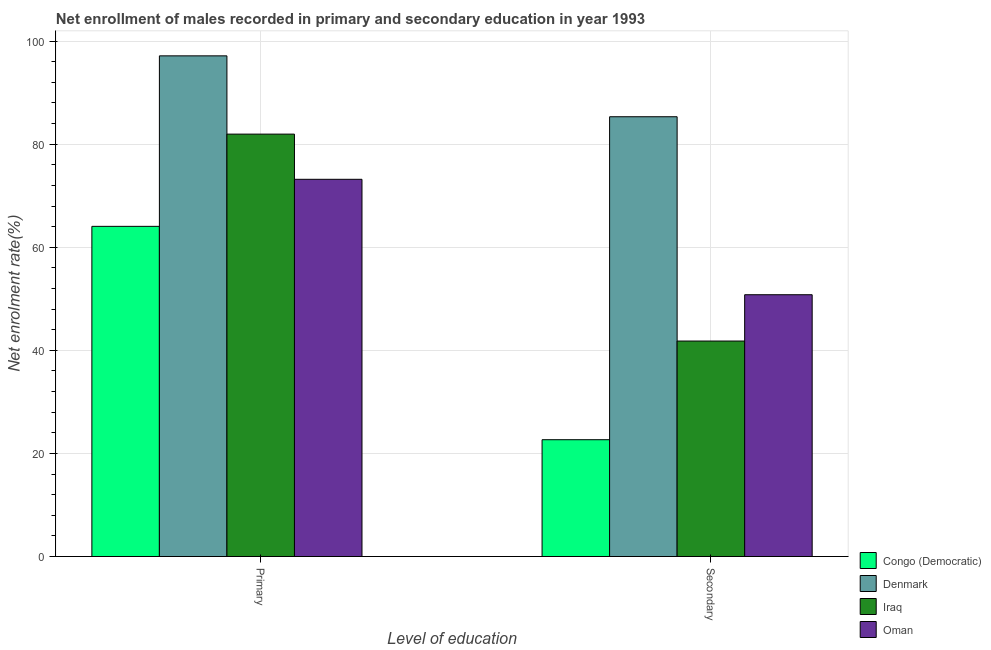How many different coloured bars are there?
Your answer should be compact. 4. Are the number of bars per tick equal to the number of legend labels?
Provide a succinct answer. Yes. Are the number of bars on each tick of the X-axis equal?
Offer a terse response. Yes. How many bars are there on the 1st tick from the right?
Make the answer very short. 4. What is the label of the 2nd group of bars from the left?
Your answer should be compact. Secondary. What is the enrollment rate in secondary education in Iraq?
Your response must be concise. 41.8. Across all countries, what is the maximum enrollment rate in primary education?
Provide a short and direct response. 97.13. Across all countries, what is the minimum enrollment rate in secondary education?
Offer a very short reply. 22.66. In which country was the enrollment rate in secondary education minimum?
Your answer should be compact. Congo (Democratic). What is the total enrollment rate in primary education in the graph?
Your response must be concise. 316.31. What is the difference between the enrollment rate in secondary education in Congo (Democratic) and that in Oman?
Your answer should be very brief. -28.13. What is the difference between the enrollment rate in primary education in Iraq and the enrollment rate in secondary education in Congo (Democratic)?
Your answer should be very brief. 59.29. What is the average enrollment rate in secondary education per country?
Give a very brief answer. 50.14. What is the difference between the enrollment rate in primary education and enrollment rate in secondary education in Oman?
Your answer should be compact. 22.39. What is the ratio of the enrollment rate in primary education in Denmark to that in Oman?
Give a very brief answer. 1.33. What does the 3rd bar from the left in Secondary represents?
Your response must be concise. Iraq. What does the 3rd bar from the right in Primary represents?
Ensure brevity in your answer.  Denmark. How many bars are there?
Give a very brief answer. 8. Are all the bars in the graph horizontal?
Your response must be concise. No. How many countries are there in the graph?
Keep it short and to the point. 4. Are the values on the major ticks of Y-axis written in scientific E-notation?
Your answer should be compact. No. Does the graph contain any zero values?
Provide a short and direct response. No. Does the graph contain grids?
Your answer should be very brief. Yes. Where does the legend appear in the graph?
Keep it short and to the point. Bottom right. What is the title of the graph?
Make the answer very short. Net enrollment of males recorded in primary and secondary education in year 1993. What is the label or title of the X-axis?
Offer a very short reply. Level of education. What is the label or title of the Y-axis?
Provide a short and direct response. Net enrolment rate(%). What is the Net enrolment rate(%) of Congo (Democratic) in Primary?
Your answer should be compact. 64.05. What is the Net enrolment rate(%) of Denmark in Primary?
Offer a very short reply. 97.13. What is the Net enrolment rate(%) of Iraq in Primary?
Make the answer very short. 81.95. What is the Net enrolment rate(%) in Oman in Primary?
Give a very brief answer. 73.18. What is the Net enrolment rate(%) in Congo (Democratic) in Secondary?
Your answer should be compact. 22.66. What is the Net enrolment rate(%) of Denmark in Secondary?
Your answer should be compact. 85.32. What is the Net enrolment rate(%) in Iraq in Secondary?
Provide a succinct answer. 41.8. What is the Net enrolment rate(%) of Oman in Secondary?
Give a very brief answer. 50.79. Across all Level of education, what is the maximum Net enrolment rate(%) in Congo (Democratic)?
Make the answer very short. 64.05. Across all Level of education, what is the maximum Net enrolment rate(%) of Denmark?
Offer a terse response. 97.13. Across all Level of education, what is the maximum Net enrolment rate(%) of Iraq?
Offer a terse response. 81.95. Across all Level of education, what is the maximum Net enrolment rate(%) of Oman?
Your answer should be compact. 73.18. Across all Level of education, what is the minimum Net enrolment rate(%) in Congo (Democratic)?
Your answer should be compact. 22.66. Across all Level of education, what is the minimum Net enrolment rate(%) of Denmark?
Provide a succinct answer. 85.32. Across all Level of education, what is the minimum Net enrolment rate(%) in Iraq?
Your answer should be very brief. 41.8. Across all Level of education, what is the minimum Net enrolment rate(%) in Oman?
Offer a very short reply. 50.79. What is the total Net enrolment rate(%) in Congo (Democratic) in the graph?
Keep it short and to the point. 86.72. What is the total Net enrolment rate(%) in Denmark in the graph?
Give a very brief answer. 182.45. What is the total Net enrolment rate(%) in Iraq in the graph?
Your answer should be very brief. 123.75. What is the total Net enrolment rate(%) in Oman in the graph?
Ensure brevity in your answer.  123.97. What is the difference between the Net enrolment rate(%) of Congo (Democratic) in Primary and that in Secondary?
Offer a terse response. 41.39. What is the difference between the Net enrolment rate(%) in Denmark in Primary and that in Secondary?
Keep it short and to the point. 11.81. What is the difference between the Net enrolment rate(%) in Iraq in Primary and that in Secondary?
Your answer should be compact. 40.14. What is the difference between the Net enrolment rate(%) of Oman in Primary and that in Secondary?
Your answer should be compact. 22.39. What is the difference between the Net enrolment rate(%) of Congo (Democratic) in Primary and the Net enrolment rate(%) of Denmark in Secondary?
Offer a terse response. -21.26. What is the difference between the Net enrolment rate(%) in Congo (Democratic) in Primary and the Net enrolment rate(%) in Iraq in Secondary?
Give a very brief answer. 22.25. What is the difference between the Net enrolment rate(%) in Congo (Democratic) in Primary and the Net enrolment rate(%) in Oman in Secondary?
Provide a short and direct response. 13.27. What is the difference between the Net enrolment rate(%) in Denmark in Primary and the Net enrolment rate(%) in Iraq in Secondary?
Your response must be concise. 55.33. What is the difference between the Net enrolment rate(%) in Denmark in Primary and the Net enrolment rate(%) in Oman in Secondary?
Provide a succinct answer. 46.34. What is the difference between the Net enrolment rate(%) in Iraq in Primary and the Net enrolment rate(%) in Oman in Secondary?
Your answer should be very brief. 31.16. What is the average Net enrolment rate(%) in Congo (Democratic) per Level of education?
Provide a short and direct response. 43.36. What is the average Net enrolment rate(%) of Denmark per Level of education?
Keep it short and to the point. 91.22. What is the average Net enrolment rate(%) in Iraq per Level of education?
Your answer should be very brief. 61.88. What is the average Net enrolment rate(%) of Oman per Level of education?
Provide a succinct answer. 61.98. What is the difference between the Net enrolment rate(%) in Congo (Democratic) and Net enrolment rate(%) in Denmark in Primary?
Your response must be concise. -33.08. What is the difference between the Net enrolment rate(%) in Congo (Democratic) and Net enrolment rate(%) in Iraq in Primary?
Offer a terse response. -17.89. What is the difference between the Net enrolment rate(%) of Congo (Democratic) and Net enrolment rate(%) of Oman in Primary?
Your answer should be compact. -9.13. What is the difference between the Net enrolment rate(%) of Denmark and Net enrolment rate(%) of Iraq in Primary?
Make the answer very short. 15.18. What is the difference between the Net enrolment rate(%) in Denmark and Net enrolment rate(%) in Oman in Primary?
Ensure brevity in your answer.  23.95. What is the difference between the Net enrolment rate(%) in Iraq and Net enrolment rate(%) in Oman in Primary?
Your answer should be very brief. 8.77. What is the difference between the Net enrolment rate(%) in Congo (Democratic) and Net enrolment rate(%) in Denmark in Secondary?
Provide a short and direct response. -62.66. What is the difference between the Net enrolment rate(%) of Congo (Democratic) and Net enrolment rate(%) of Iraq in Secondary?
Offer a terse response. -19.14. What is the difference between the Net enrolment rate(%) of Congo (Democratic) and Net enrolment rate(%) of Oman in Secondary?
Offer a very short reply. -28.13. What is the difference between the Net enrolment rate(%) of Denmark and Net enrolment rate(%) of Iraq in Secondary?
Your answer should be very brief. 43.52. What is the difference between the Net enrolment rate(%) of Denmark and Net enrolment rate(%) of Oman in Secondary?
Offer a terse response. 34.53. What is the difference between the Net enrolment rate(%) of Iraq and Net enrolment rate(%) of Oman in Secondary?
Your response must be concise. -8.98. What is the ratio of the Net enrolment rate(%) of Congo (Democratic) in Primary to that in Secondary?
Provide a succinct answer. 2.83. What is the ratio of the Net enrolment rate(%) of Denmark in Primary to that in Secondary?
Provide a succinct answer. 1.14. What is the ratio of the Net enrolment rate(%) of Iraq in Primary to that in Secondary?
Provide a succinct answer. 1.96. What is the ratio of the Net enrolment rate(%) of Oman in Primary to that in Secondary?
Give a very brief answer. 1.44. What is the difference between the highest and the second highest Net enrolment rate(%) of Congo (Democratic)?
Your answer should be compact. 41.39. What is the difference between the highest and the second highest Net enrolment rate(%) in Denmark?
Keep it short and to the point. 11.81. What is the difference between the highest and the second highest Net enrolment rate(%) in Iraq?
Offer a terse response. 40.14. What is the difference between the highest and the second highest Net enrolment rate(%) of Oman?
Provide a succinct answer. 22.39. What is the difference between the highest and the lowest Net enrolment rate(%) of Congo (Democratic)?
Give a very brief answer. 41.39. What is the difference between the highest and the lowest Net enrolment rate(%) in Denmark?
Give a very brief answer. 11.81. What is the difference between the highest and the lowest Net enrolment rate(%) of Iraq?
Make the answer very short. 40.14. What is the difference between the highest and the lowest Net enrolment rate(%) of Oman?
Keep it short and to the point. 22.39. 